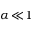Convert formula to latex. <formula><loc_0><loc_0><loc_500><loc_500>\alpha \, \ll \, 1</formula> 